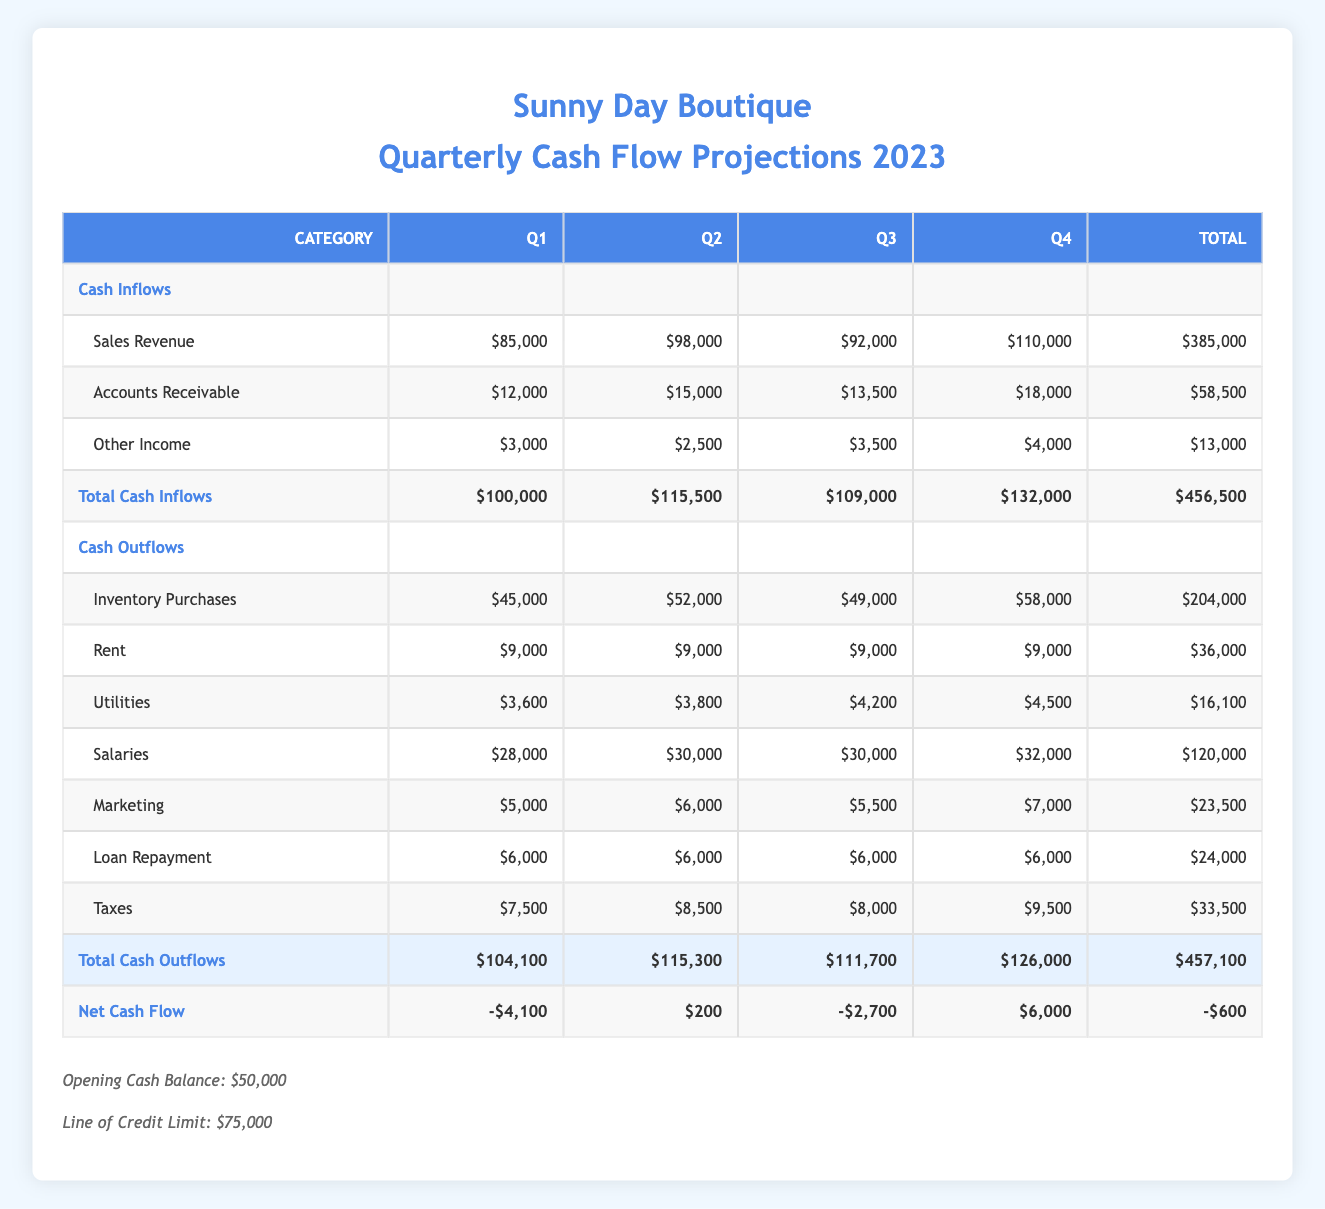What is the total cash inflow for Q3? The cash inflow for Q3 consists of sales revenue ($92,000), accounts receivable ($13,500), and other income ($3,500). Adding these amounts gives a total of $92,000 + $13,500 + $3,500 = $109,000.
Answer: 109,000 How much did Sunny Day Boutique spend on salaries in total for the year? The total salaries for each quarter are as follows: Q1 ($28,000), Q2 ($30,000), Q3 ($30,000), Q4 ($32,000). Summing these amounts provides the total: $28,000 + $30,000 + $30,000 + $32,000 = $120,000.
Answer: 120,000 Did the business have a positive net cash flow in Q2? The net cash flow for Q2 is $200, which is a positive value. Therefore, the business did have a positive net cash flow in Q2.
Answer: Yes What is the average cash inflow per quarter? The total cash inflows across all quarters are $456,500. There are 4 quarters in total, so the average cash inflow per quarter is calculated as $456,500 / 4 = $114,125.
Answer: 114,125 What was the highest cash outflow in any quarter, and in which quarter did it occur? The cash outflows for each quarter are: Q1 ($104,100), Q2 ($115,300), Q3 ($111,700), Q4 ($126,000). The highest cash outflow is $126,000 in Q4.
Answer: 126,000 in Q4 If the business had an opening cash balance of $50,000, what was the cash position at the end of Q4? To find the cash position at the end of Q4, we start with the opening cash balance and then add the total cash inflow for Q4 ($132,000) while subtracting the total cash outflow for Q4 ($126,000). Thus, end cash position = $50,000 + $132,000 - $126,000 = $56,000.
Answer: 56,000 Which quarter experienced the largest increase in cash inflow compared to the previous quarter? The cash inflow for each quarter is as follows: Q1 ($100,000), Q2 ($115,500), Q3 ($109,000), and Q4 ($132,000). The increase from Q3 to Q4 is $132,000 - $109,000 = $23,000, while from Q1 to Q2 is $115,500 - $100,000 = $15,500, and from Q2 to Q3 is $109,000 - $115,500 = -$6,500. Therefore, the largest increase is from Q3 to Q4 with an increase of $23,000.
Answer: Q4 Was the total cash outflow in Q4 higher than that in Q1? The total cash outflow for Q4 is $126,000, and for Q1 it is $104,100. Since $126,000 is greater than $104,100, the statement is true.
Answer: Yes 